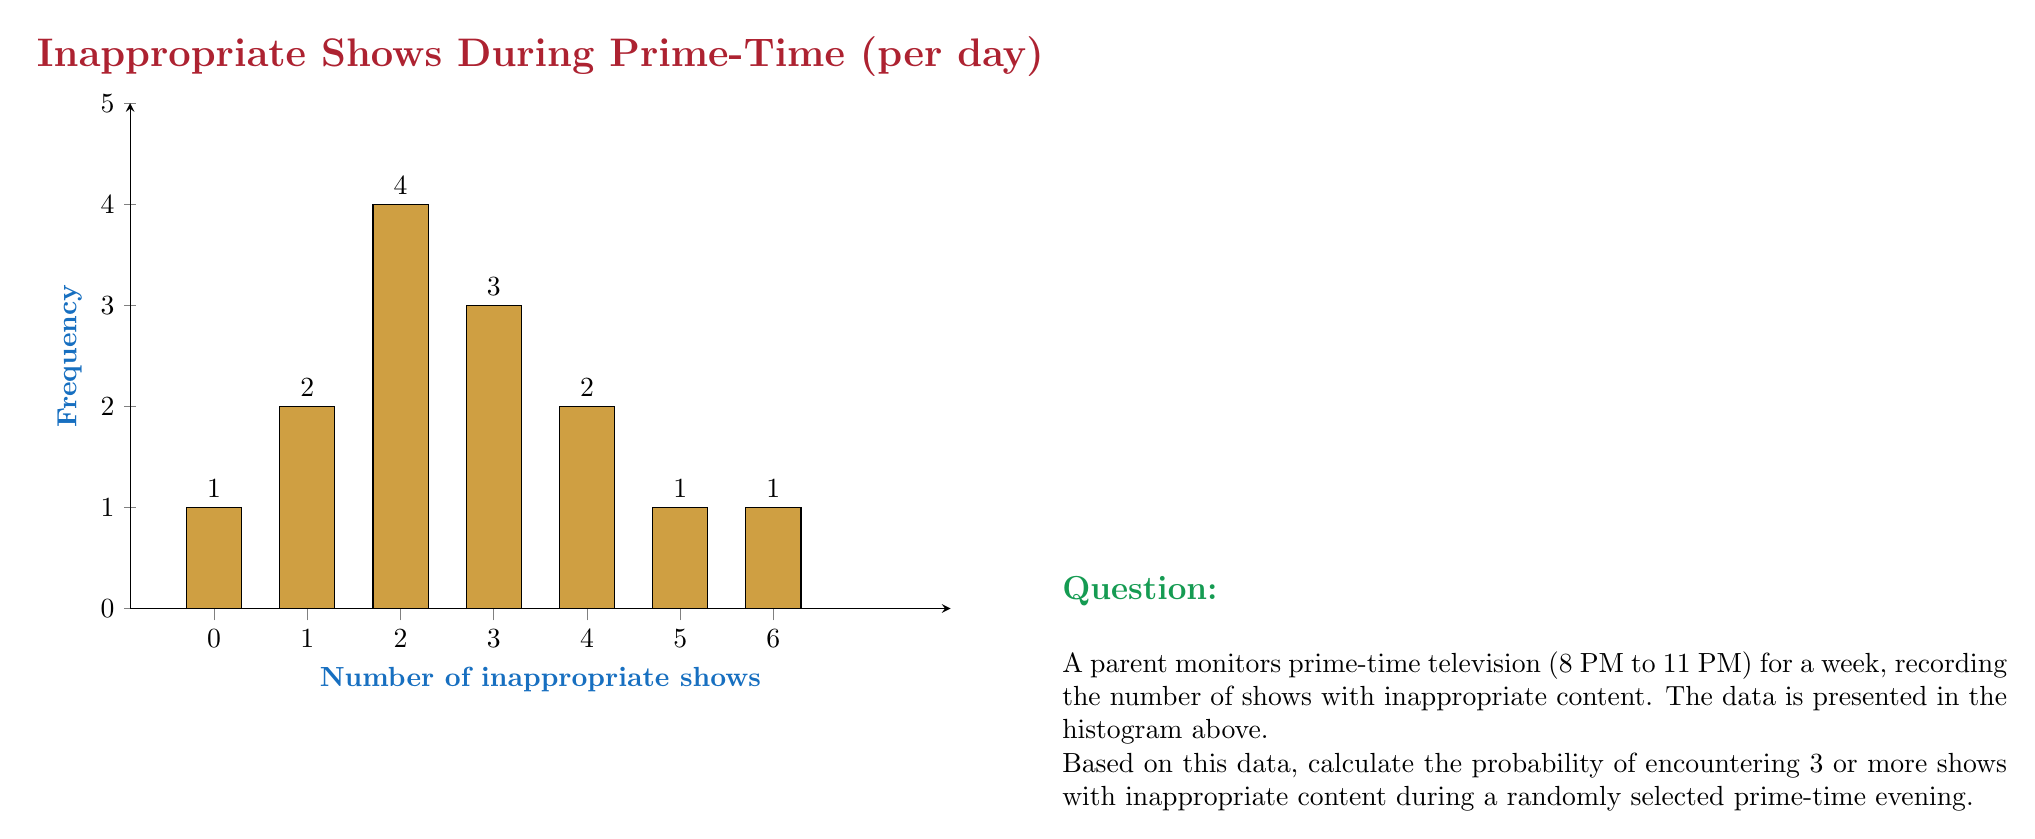Can you solve this math problem? To solve this problem, we'll follow these steps:

1) First, let's calculate the total number of evenings observed:
   $$1 + 2 + 4 + 3 + 2 + 1 + 1 = 14$$ evenings

2) Now, we need to find the number of evenings with 3 or more inappropriate shows:
   3 inappropriate shows: 3 evenings
   4 inappropriate shows: 2 evenings
   5 inappropriate shows: 1 evening
   6 inappropriate shows: 1 evening
   Total: $3 + 2 + 1 + 1 = 7$ evenings

3) The probability is calculated by dividing the number of favorable outcomes by the total number of possible outcomes:

   $$P(\text{3 or more inappropriate shows}) = \frac{\text{Evenings with 3 or more inappropriate shows}}{\text{Total evenings}}$$

   $$P(\text{3 or more inappropriate shows}) = \frac{7}{14} = \frac{1}{2} = 0.5$$

Therefore, the probability of encountering 3 or more shows with inappropriate content during a randomly selected prime-time evening is 0.5 or 50%.
Answer: 0.5 